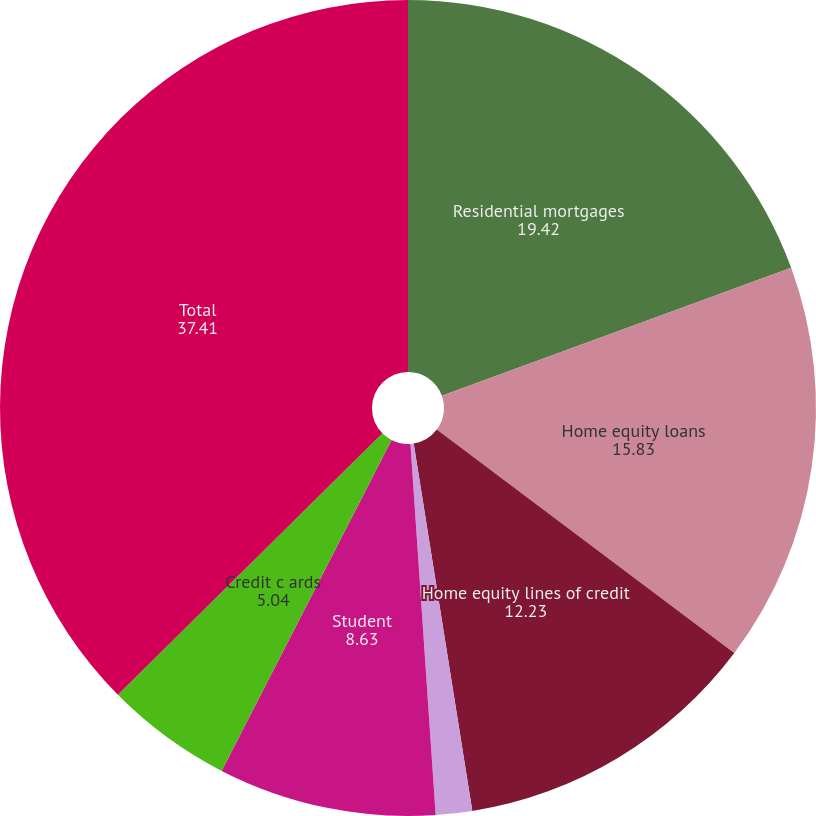Convert chart. <chart><loc_0><loc_0><loc_500><loc_500><pie_chart><fcel>Residential mortgages<fcel>Home equity loans<fcel>Home equity lines of credit<fcel>Home equity loans serviced by<fcel>Student<fcel>Credit c ards<fcel>Total<nl><fcel>19.42%<fcel>15.83%<fcel>12.23%<fcel>1.44%<fcel>8.63%<fcel>5.04%<fcel>37.41%<nl></chart> 